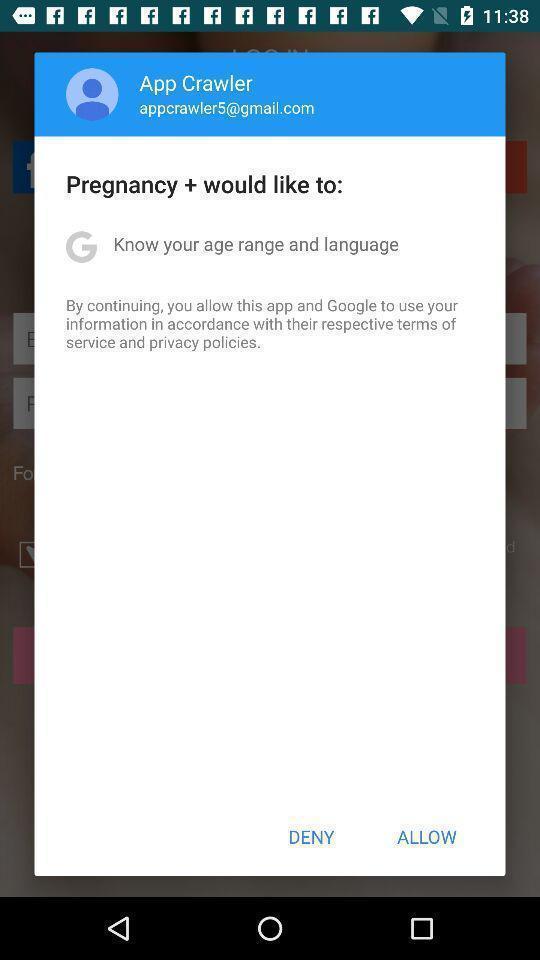Tell me about the visual elements in this screen capture. Pop-up showing to give permission to a pregnancy app. 